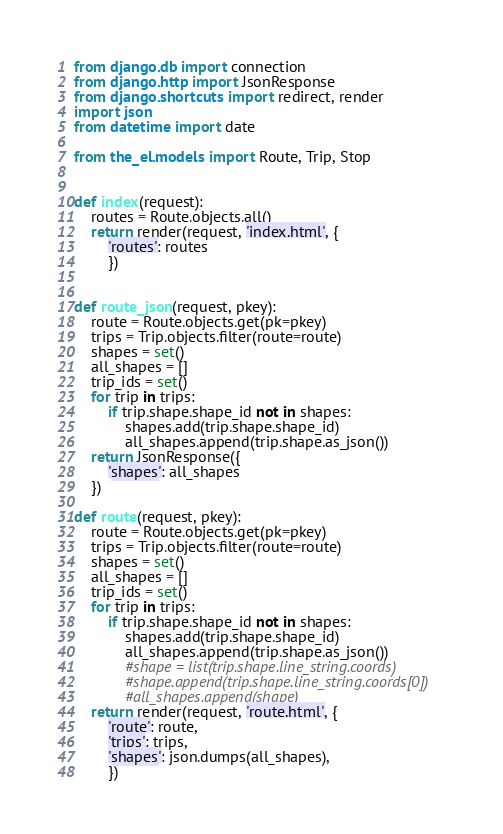<code> <loc_0><loc_0><loc_500><loc_500><_Python_>from django.db import connection
from django.http import JsonResponse
from django.shortcuts import redirect, render
import json
from datetime import date

from the_el.models import Route, Trip, Stop


def index(request):
    routes = Route.objects.all()
    return render(request, 'index.html', {
        'routes': routes
        })


def route_json(request, pkey):
    route = Route.objects.get(pk=pkey)
    trips = Trip.objects.filter(route=route)
    shapes = set()
    all_shapes = []
    trip_ids = set()
    for trip in trips:
        if trip.shape.shape_id not in shapes:
            shapes.add(trip.shape.shape_id)
            all_shapes.append(trip.shape.as_json())
    return JsonResponse({
        'shapes': all_shapes
    })

def route(request, pkey):
    route = Route.objects.get(pk=pkey)
    trips = Trip.objects.filter(route=route)
    shapes = set()
    all_shapes = []
    trip_ids = set()
    for trip in trips:
        if trip.shape.shape_id not in shapes:
            shapes.add(trip.shape.shape_id)
            all_shapes.append(trip.shape.as_json())
            #shape = list(trip.shape.line_string.coords)
            #shape.append(trip.shape.line_string.coords[0])
            #all_shapes.append(shape)
    return render(request, 'route.html', {
        'route': route,
        'trips': trips,
        'shapes': json.dumps(all_shapes),
        })
</code> 